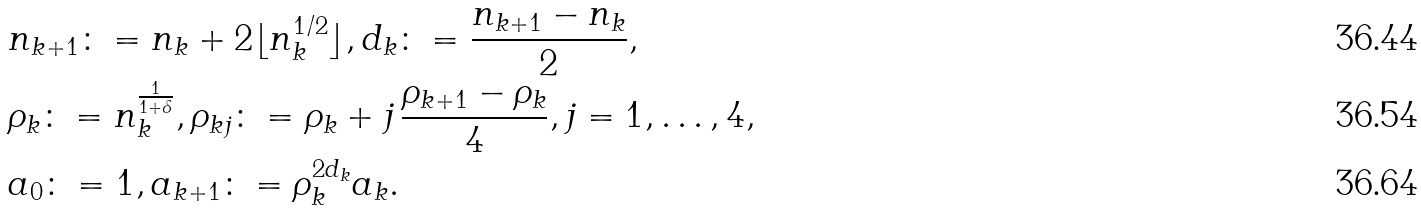<formula> <loc_0><loc_0><loc_500><loc_500>& n _ { k + 1 } \colon = n _ { k } + 2 \lfloor n _ { k } ^ { 1 / 2 } \rfloor , d _ { k } \colon = \frac { n _ { k + 1 } - n _ { k } } { 2 } , \\ & \rho _ { k } \colon = n _ { k } ^ { \frac { 1 } { 1 + \delta } } , \rho _ { k j } \colon = \rho _ { k } + j \, \frac { \rho _ { k + 1 } - \rho _ { k } } { 4 } , j = 1 , \dots , 4 , \\ & a _ { 0 } \colon = 1 , a _ { k + 1 } \colon = \rho _ { k } ^ { 2 d _ { k } } a _ { k } .</formula> 